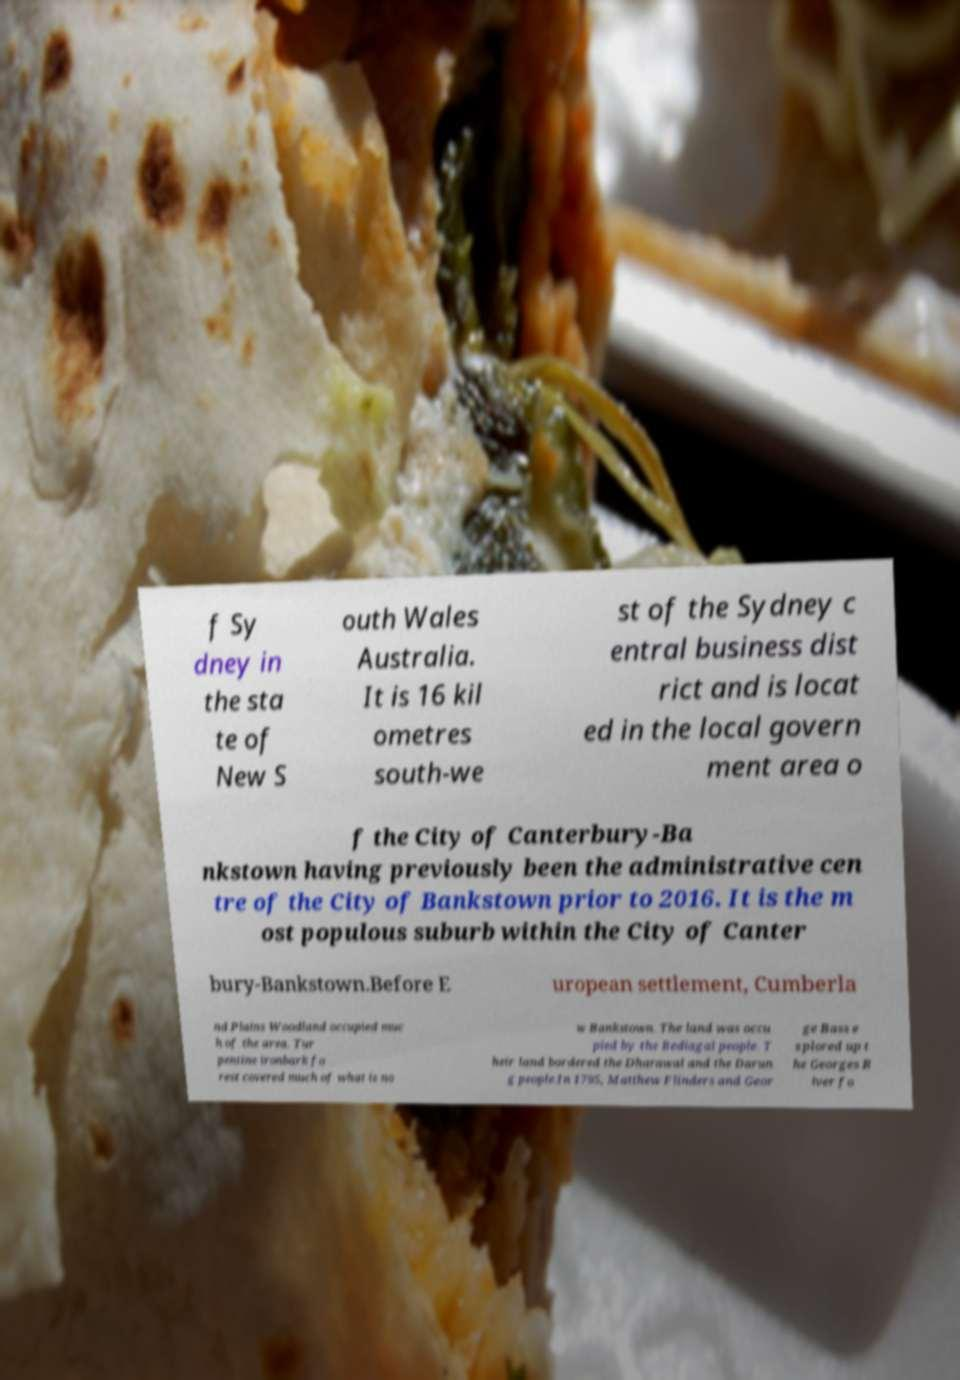What messages or text are displayed in this image? I need them in a readable, typed format. f Sy dney in the sta te of New S outh Wales Australia. It is 16 kil ometres south-we st of the Sydney c entral business dist rict and is locat ed in the local govern ment area o f the City of Canterbury-Ba nkstown having previously been the administrative cen tre of the City of Bankstown prior to 2016. It is the m ost populous suburb within the City of Canter bury-Bankstown.Before E uropean settlement, Cumberla nd Plains Woodland occupied muc h of the area. Tur pentine ironbark fo rest covered much of what is no w Bankstown. The land was occu pied by the Bediagal people. T heir land bordered the Dharawal and the Darun g people.In 1795, Matthew Flinders and Geor ge Bass e xplored up t he Georges R iver fo 